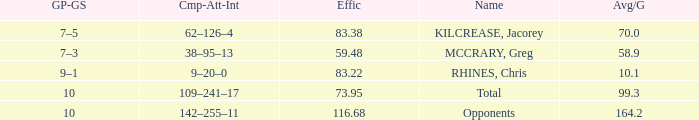What is the total avg/g of McCrary, Greg? 1.0. 